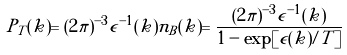Convert formula to latex. <formula><loc_0><loc_0><loc_500><loc_500>P _ { T } ( k ) = ( 2 \pi ) ^ { - 3 } \epsilon ^ { - 1 } ( k ) n _ { B } ( k ) = \frac { ( 2 \pi ) ^ { - 3 } \epsilon ^ { - 1 } ( k ) } { 1 - \exp [ \epsilon ( k ) / T ] }</formula> 